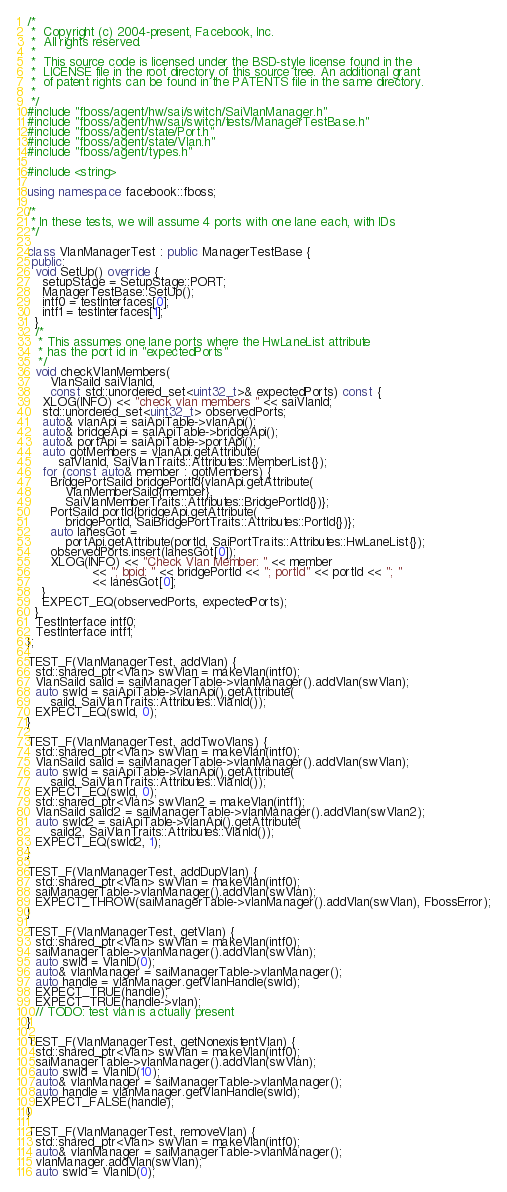<code> <loc_0><loc_0><loc_500><loc_500><_C++_>/*
 *  Copyright (c) 2004-present, Facebook, Inc.
 *  All rights reserved.
 *
 *  This source code is licensed under the BSD-style license found in the
 *  LICENSE file in the root directory of this source tree. An additional grant
 *  of patent rights can be found in the PATENTS file in the same directory.
 *
 */
#include "fboss/agent/hw/sai/switch/SaiVlanManager.h"
#include "fboss/agent/hw/sai/switch/tests/ManagerTestBase.h"
#include "fboss/agent/state/Port.h"
#include "fboss/agent/state/Vlan.h"
#include "fboss/agent/types.h"

#include <string>

using namespace facebook::fboss;

/*
 * In these tests, we will assume 4 ports with one lane each, with IDs
 */

class VlanManagerTest : public ManagerTestBase {
 public:
  void SetUp() override {
    setupStage = SetupStage::PORT;
    ManagerTestBase::SetUp();
    intf0 = testInterfaces[0];
    intf1 = testInterfaces[1];
  }
  /*
   * This assumes one lane ports where the HwLaneList attribute
   * has the port id in "expectedPorts"
   */
  void checkVlanMembers(
      VlanSaiId saiVlanId,
      const std::unordered_set<uint32_t>& expectedPorts) const {
    XLOG(INFO) << "check vlan members " << saiVlanId;
    std::unordered_set<uint32_t> observedPorts;
    auto& vlanApi = saiApiTable->vlanApi();
    auto& bridgeApi = saiApiTable->bridgeApi();
    auto& portApi = saiApiTable->portApi();
    auto gotMembers = vlanApi.getAttribute(
        saiVlanId, SaiVlanTraits::Attributes::MemberList{});
    for (const auto& member : gotMembers) {
      BridgePortSaiId bridgePortId{vlanApi.getAttribute(
          VlanMemberSaiId{member},
          SaiVlanMemberTraits::Attributes::BridgePortId{})};
      PortSaiId portId{bridgeApi.getAttribute(
          bridgePortId, SaiBridgePortTraits::Attributes::PortId{})};
      auto lanesGot =
          portApi.getAttribute(portId, SaiPortTraits::Attributes::HwLaneList{});
      observedPorts.insert(lanesGot[0]);
      XLOG(INFO) << "Check Vlan Member: " << member
                 << "; bpid: " << bridgePortId << "; portId" << portId << "; "
                 << lanesGot[0];
    }
    EXPECT_EQ(observedPorts, expectedPorts);
  }
  TestInterface intf0;
  TestInterface intf1;
};

TEST_F(VlanManagerTest, addVlan) {
  std::shared_ptr<Vlan> swVlan = makeVlan(intf0);
  VlanSaiId saiId = saiManagerTable->vlanManager().addVlan(swVlan);
  auto swId = saiApiTable->vlanApi().getAttribute(
      saiId, SaiVlanTraits::Attributes::VlanId());
  EXPECT_EQ(swId, 0);
}

TEST_F(VlanManagerTest, addTwoVlans) {
  std::shared_ptr<Vlan> swVlan = makeVlan(intf0);
  VlanSaiId saiId = saiManagerTable->vlanManager().addVlan(swVlan);
  auto swId = saiApiTable->vlanApi().getAttribute(
      saiId, SaiVlanTraits::Attributes::VlanId());
  EXPECT_EQ(swId, 0);
  std::shared_ptr<Vlan> swVlan2 = makeVlan(intf1);
  VlanSaiId saiId2 = saiManagerTable->vlanManager().addVlan(swVlan2);
  auto swId2 = saiApiTable->vlanApi().getAttribute(
      saiId2, SaiVlanTraits::Attributes::VlanId());
  EXPECT_EQ(swId2, 1);
}

TEST_F(VlanManagerTest, addDupVlan) {
  std::shared_ptr<Vlan> swVlan = makeVlan(intf0);
  saiManagerTable->vlanManager().addVlan(swVlan);
  EXPECT_THROW(saiManagerTable->vlanManager().addVlan(swVlan), FbossError);
}

TEST_F(VlanManagerTest, getVlan) {
  std::shared_ptr<Vlan> swVlan = makeVlan(intf0);
  saiManagerTable->vlanManager().addVlan(swVlan);
  auto swId = VlanID(0);
  auto& vlanManager = saiManagerTable->vlanManager();
  auto handle = vlanManager.getVlanHandle(swId);
  EXPECT_TRUE(handle);
  EXPECT_TRUE(handle->vlan);
  // TODO: test vlan is actually present
}

TEST_F(VlanManagerTest, getNonexistentVlan) {
  std::shared_ptr<Vlan> swVlan = makeVlan(intf0);
  saiManagerTable->vlanManager().addVlan(swVlan);
  auto swId = VlanID(10);
  auto& vlanManager = saiManagerTable->vlanManager();
  auto handle = vlanManager.getVlanHandle(swId);
  EXPECT_FALSE(handle);
}

TEST_F(VlanManagerTest, removeVlan) {
  std::shared_ptr<Vlan> swVlan = makeVlan(intf0);
  auto& vlanManager = saiManagerTable->vlanManager();
  vlanManager.addVlan(swVlan);
  auto swId = VlanID(0);</code> 